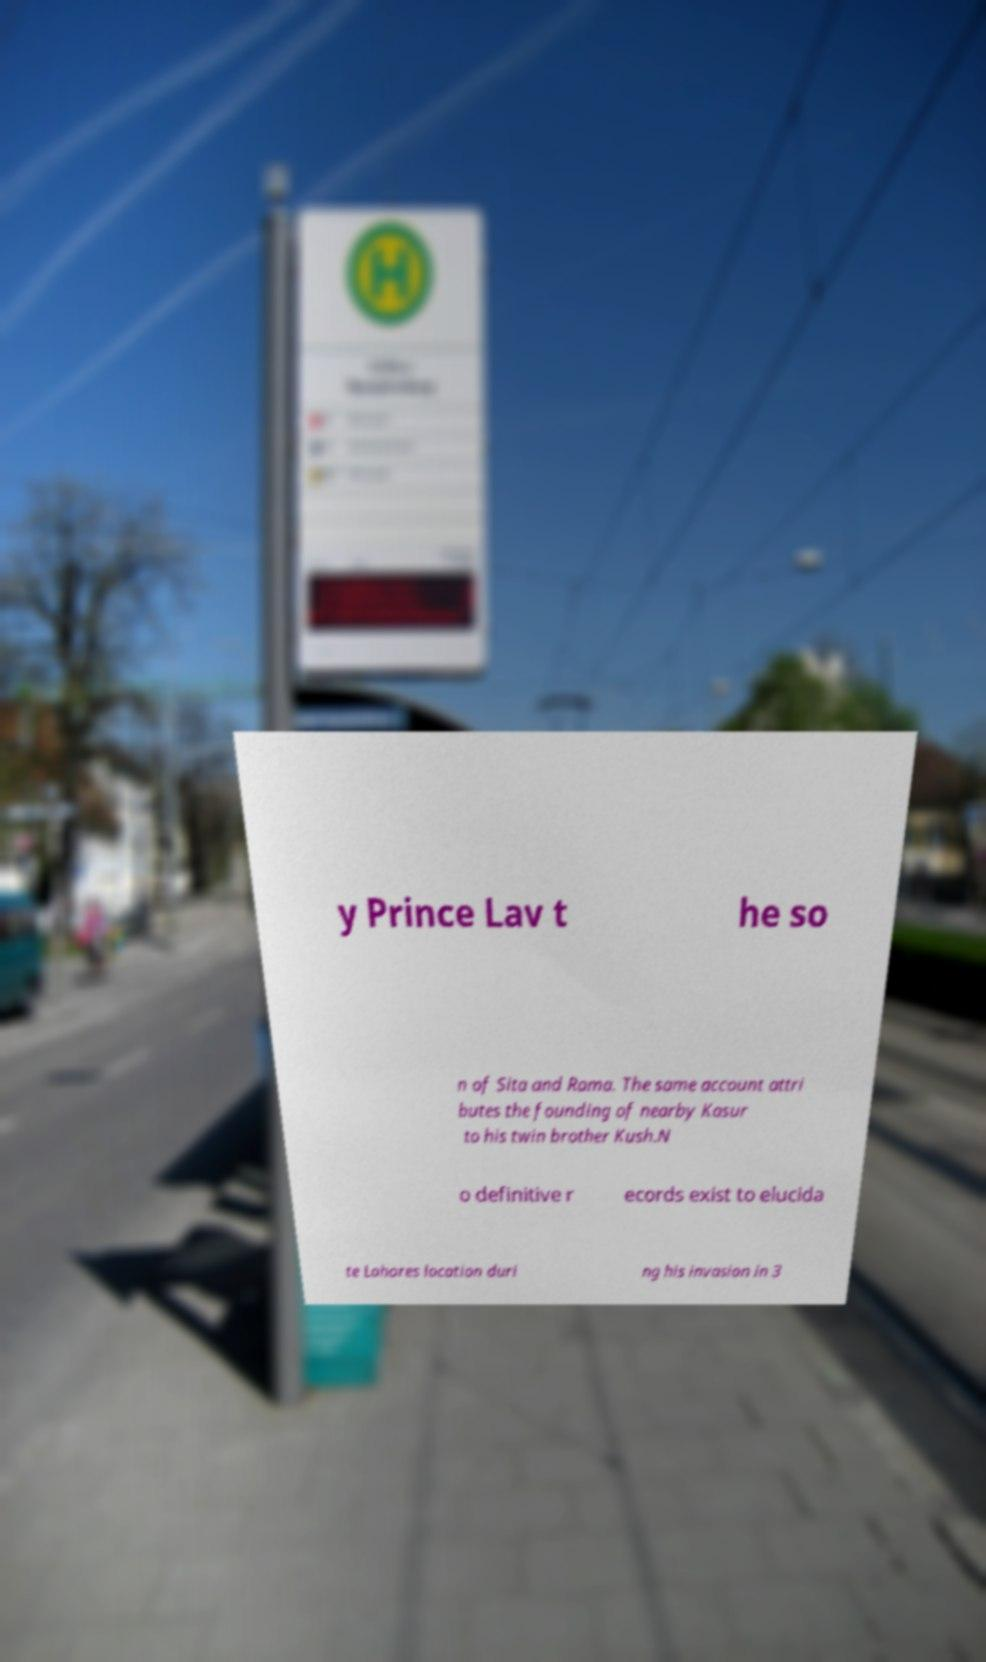Please read and relay the text visible in this image. What does it say? y Prince Lav t he so n of Sita and Rama. The same account attri butes the founding of nearby Kasur to his twin brother Kush.N o definitive r ecords exist to elucida te Lahores location duri ng his invasion in 3 